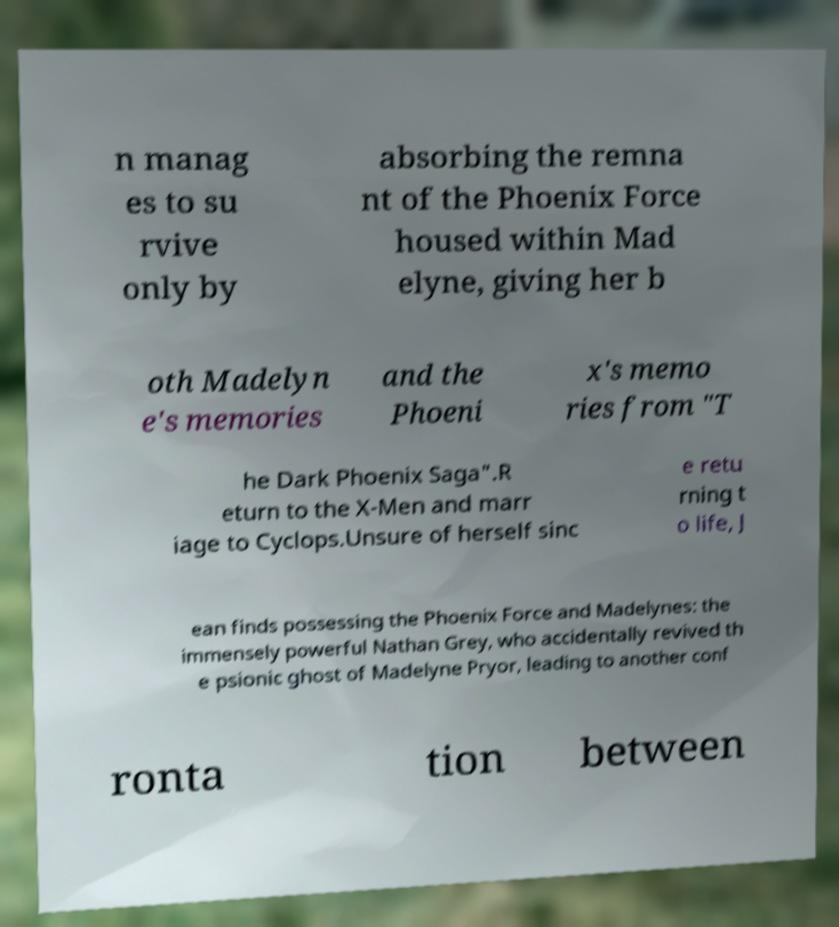Please read and relay the text visible in this image. What does it say? n manag es to su rvive only by absorbing the remna nt of the Phoenix Force housed within Mad elyne, giving her b oth Madelyn e's memories and the Phoeni x's memo ries from "T he Dark Phoenix Saga".R eturn to the X-Men and marr iage to Cyclops.Unsure of herself sinc e retu rning t o life, J ean finds possessing the Phoenix Force and Madelynes: the immensely powerful Nathan Grey, who accidentally revived th e psionic ghost of Madelyne Pryor, leading to another conf ronta tion between 